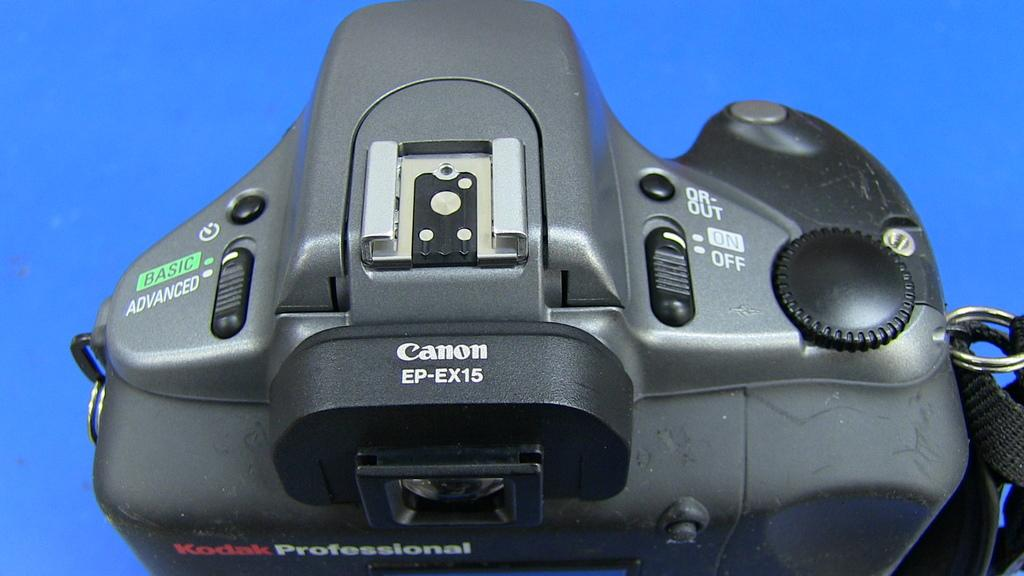<image>
Share a concise interpretation of the image provided. A Canon camera can be used to take quality professional photographs. 